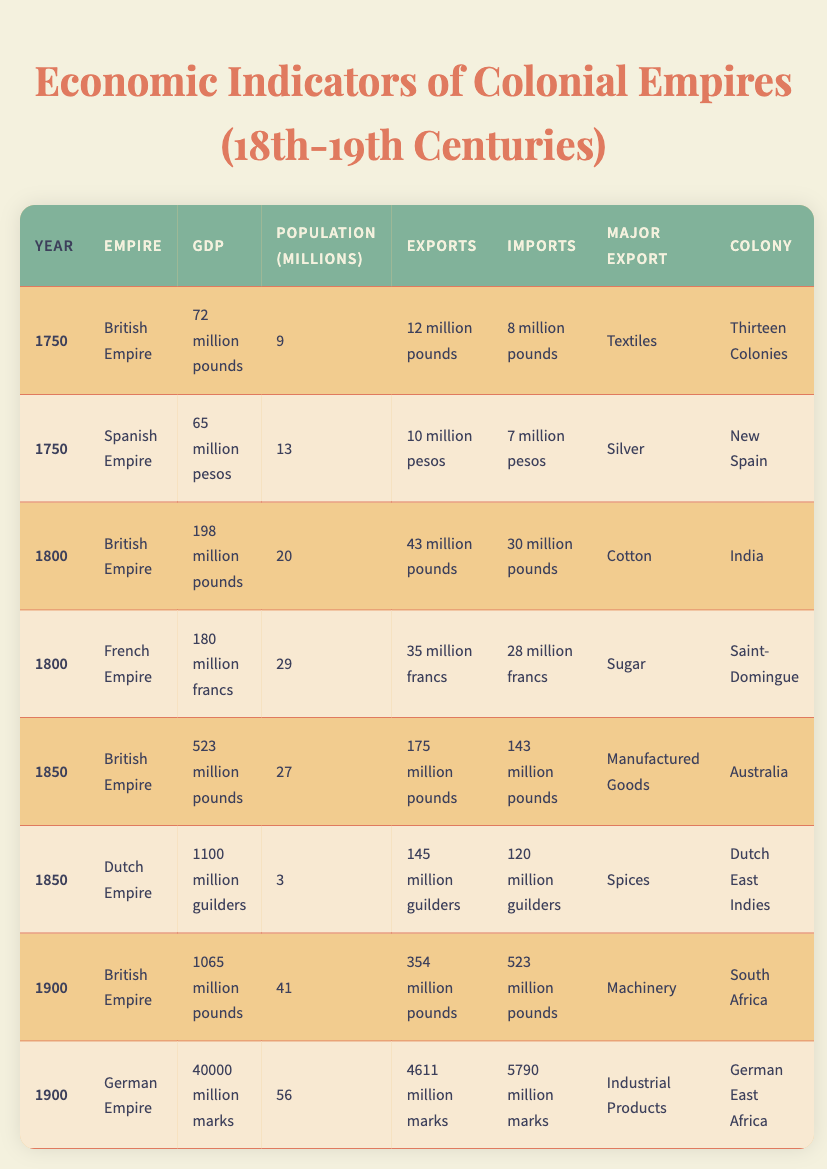What was the GDP of the British Empire in 1750? The table shows that in 1750, the GDP of the British Empire was listed as 72 million pounds.
Answer: 72 million pounds Which empire had the highest GDP in 1900? In the year 1900, the table indicates that the German Empire had a GDP of 40,000 million marks, which is higher than any other empire listed for that year.
Answer: German Empire What was the major export of the Spanish Empire in 1750? According to the table, the major export of the Spanish Empire in 1750 was silver.
Answer: Silver In which year did the British Empire first record exports greater than 175 million pounds? The table shows that the British Empire recorded exports of 175 million pounds in 1850 and then 354 million pounds in 1900. Since the first instance of greater than 175 million pounds is in 1900, this indicates that the year was 1900.
Answer: 1900 What was the difference between imports and exports for the Dutch Empire in 1850? The table provides figures for the Dutch Empire's exports in 1850 (145 million guilders) and imports (120 million guilders). The difference is calculated by subtracting imports from exports: 145 - 120 = 25 million guilders.
Answer: 25 million guilders Did the British Empire's population increase or decrease from 1750 to 1900? By looking at the population figures, the British Empire had a population of 9 million in 1750 and 41 million in 1900. Since 41 million is greater than 9 million, this indicates an increase.
Answer: Increase What was the total GDP of the British Empire across all years recorded in the table? The GDP values for the British Empire across the years 1750 (72 million pounds), 1800 (198 million pounds), 1850 (523 million pounds), and 1900 (1065 million pounds) can be summed as follows: 72 + 198 + 523 + 1065 = 1858 million pounds.
Answer: 1858 million pounds Which empire had the lowest population in 1850? The data indicates that in 1850, the Dutch Empire had a population of 3 million, which is less than that of other empires recorded for that year.
Answer: Dutch Empire 